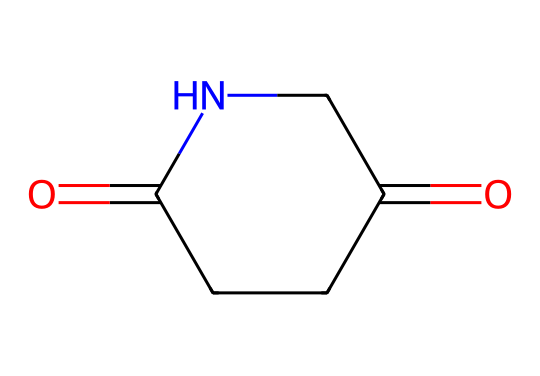What is the molecular formula of glutarimide? In the SMILES representation, the atoms present include two carbonyl groups (C=O), four carbon atoms (C), one nitrogen atom (N), and four hydrogen atoms (H). By counting each atom type, the molecular formula can be deduced as C5H7N1O2.
Answer: C5H7NO2 How many rings are present in glutarimide? The structure indicated by the SMILES shows a single cyclic structure labeled as 'C1', which signifies that there is one ring in the molecule.
Answer: 1 What type of structure characterizes glutarimide? The SMILES representation includes both an amide bond (C(=O)N) and features a ring structure, which is characteristic of imides. This, along with the presence of carbonyl groups adjacent to the nitrogen, defines it as an imide-based structure.
Answer: imide How many oxygen atoms are in glutarimide? By analyzing the SMILES representation, there are two carbonyl groups, each represented by 'O=C', which counts for two oxygen atoms in the structure.
Answer: 2 What functional groups are present in glutarimide? The structure contains a cyclic imide character due to the combination of a carbonyl (C=O) bonded to a nitrogen (N) within a ring. These carbonyls and the nitrogen bonded to form an amide category define its functional groups.
Answer: carbonyl and nitrogen What is the total number of hydrogen atoms in glutarimide? The hydrogens can be counted from the SMILES interpretation, where the central nitrogen atom forms bonds. There are four hydrogen atoms in total, as inferred from the molecular structure.
Answer: 7 